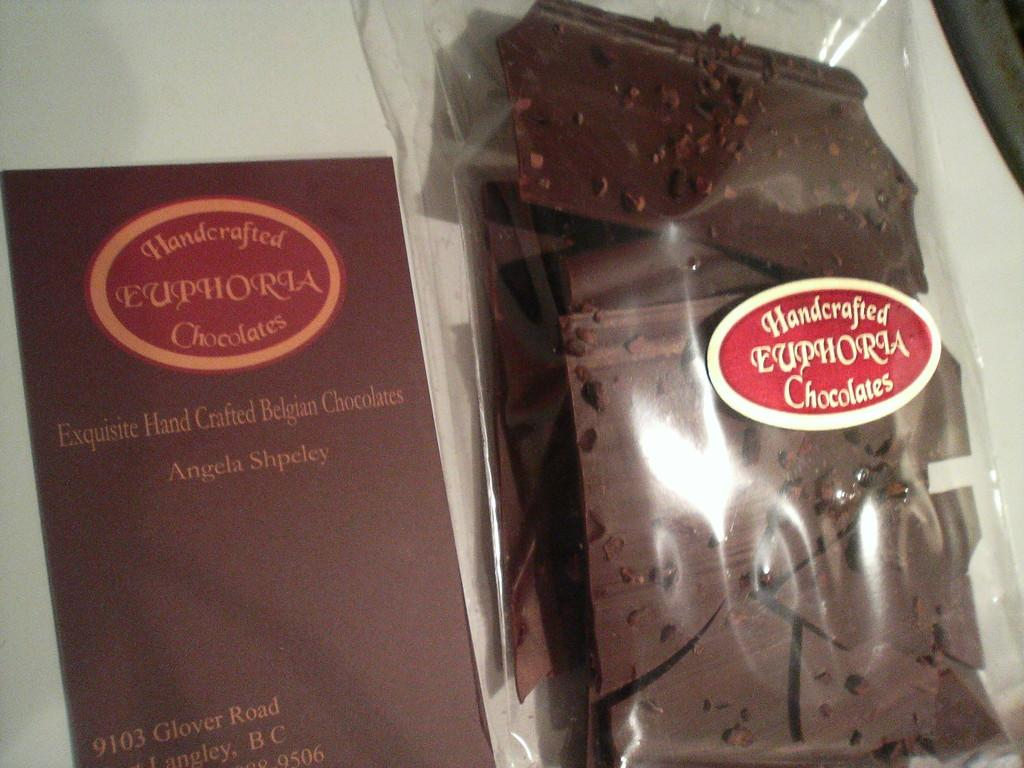<image>
Describe the image concisely. A bag of chocolates being shown next to a box that states hand crafted chocolates. 